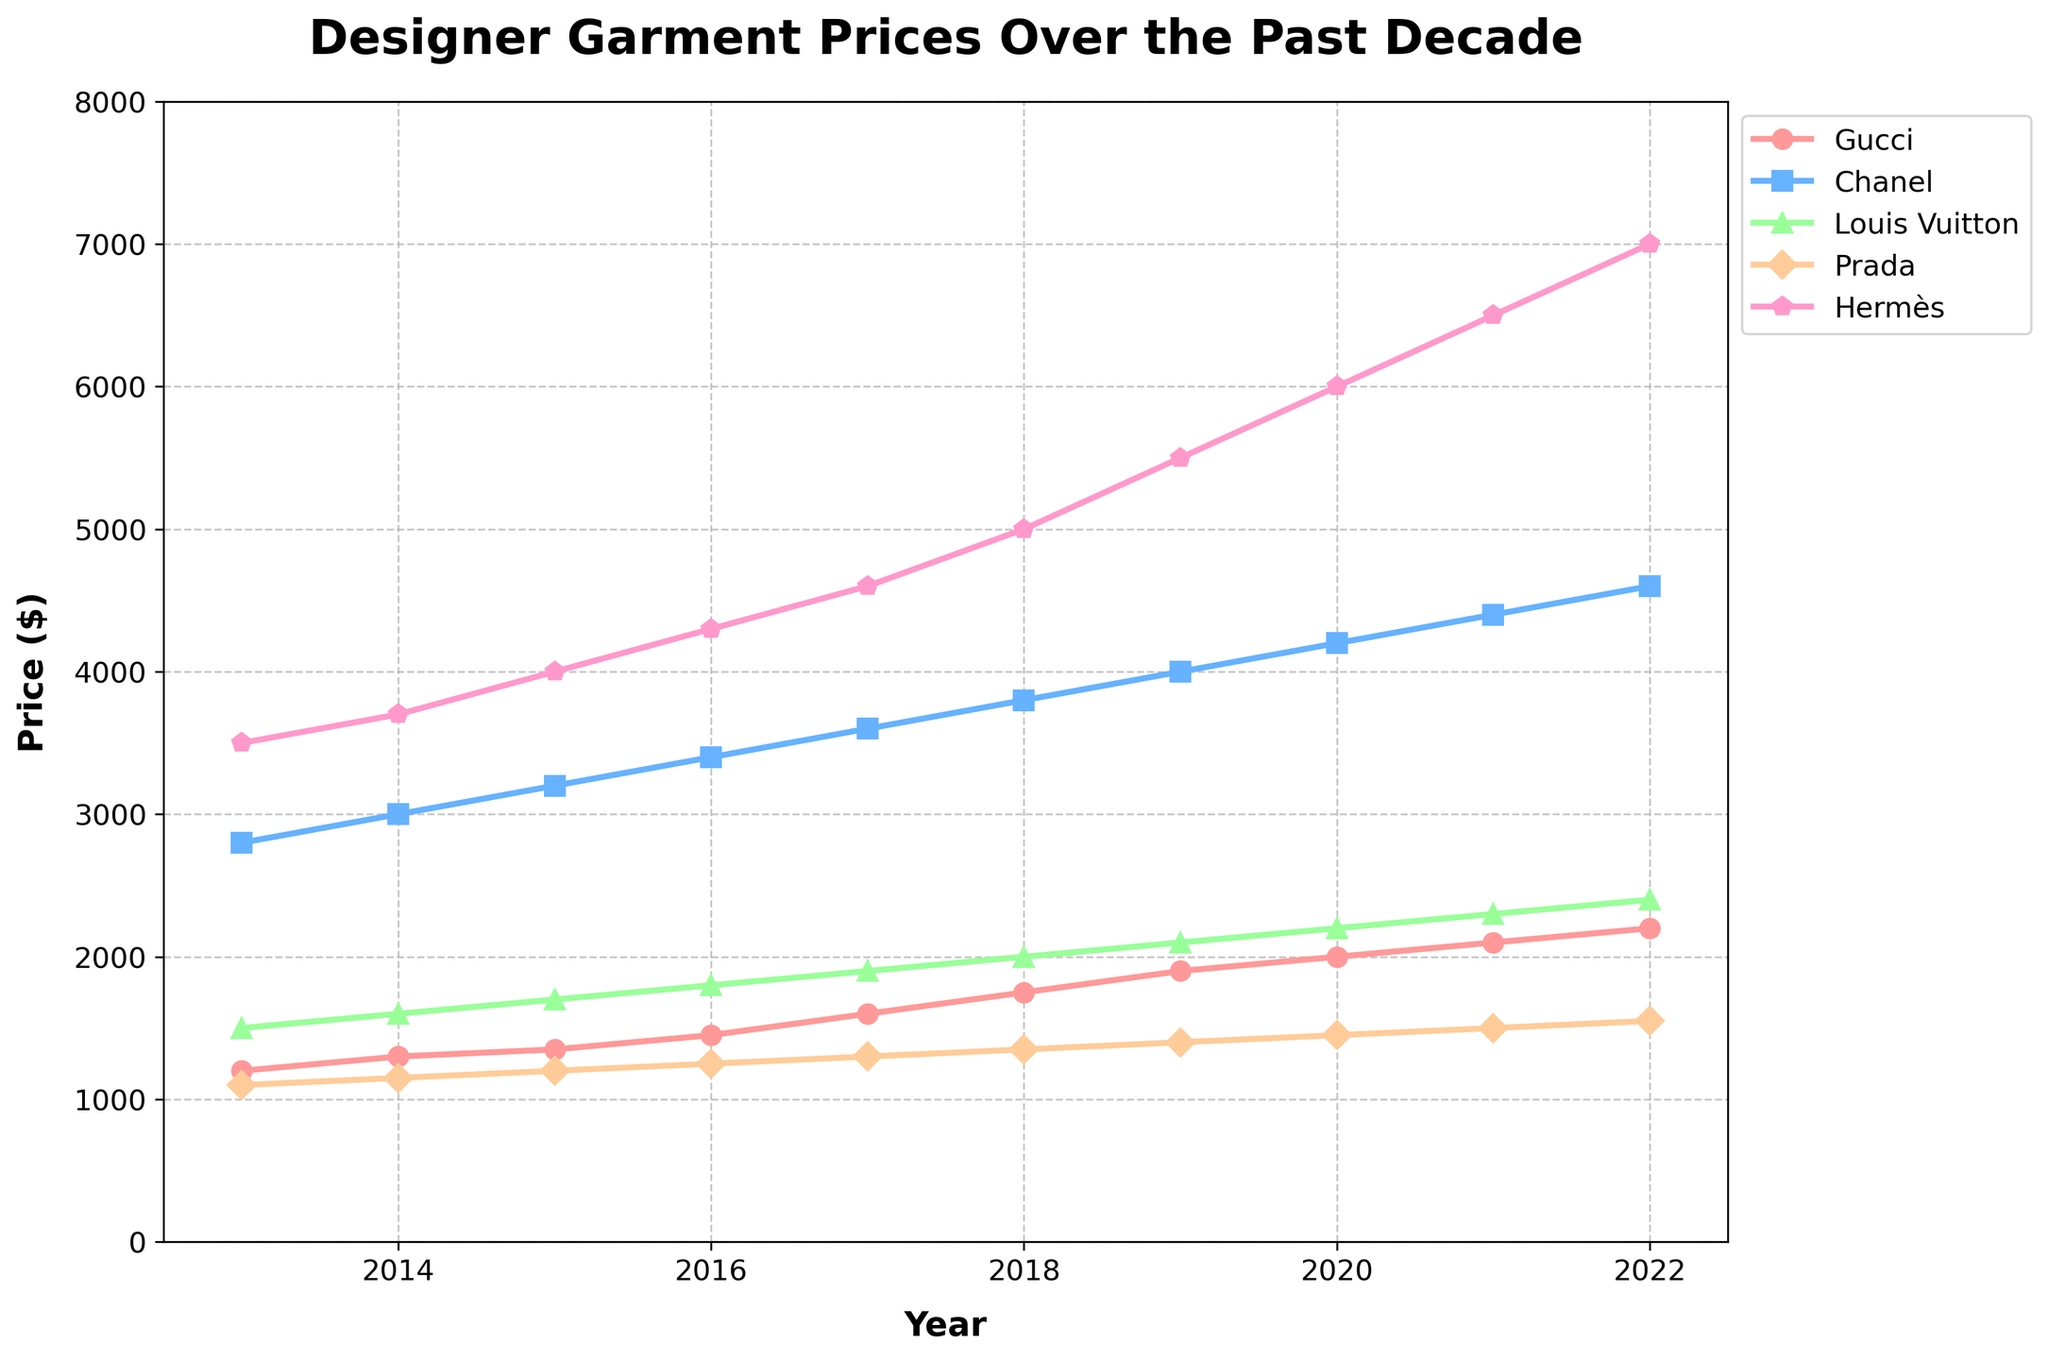What is the overall trend of designer garment prices for Gucci over the past decade? The overall trend for Gucci prices shows a steady increase from 2013 to 2022, starting at $1200 in 2013 and reaching $2200 in 2022. To determine this, observe the upward slope of the Gucci line over the years on the chart.
Answer: Steady increase Between 2013 and 2022, which brand had the highest percentage increase in garment prices? Calculate the percentage increase for each brand using the formula: (price in 2022 - price in 2013) / price in 2013 * 100%. For Hermès: (7000 - 3500) / 3500 * 100% = 100%; For Gucci: (2200 - 1200) / 1200 * 100% = 83.33%; For Chanel: (4600 - 2800) / 2800 * 100% = 64.29%; For Louis Vuitton: (2400 - 1500) / 1500 * 100% = 60%; For Prada: (1550 - 1100) / 1100 * 100% = 40.91%. Hermès has the highest percentage increase at 100%.
Answer: Hermès Which brand had the most consistent year-over-year price increase? The most consistent year-over-year price increase can be observed by identifying the brand whose line on the chart shows a nearly uniform slope without large fluctuations between years. Gucci, with a uniform increasing line from $1200 to $2200, appears most consistent.
Answer: Gucci In what year did Louis Vuitton surpass the $2000 price point? Look at the Louis Vuitton line and identify the year it crosses the $2000 price level. It crosses this level in 2022.
Answer: 2021 Compare the prices of Chanel and Prada in 2017. Which one was higher and by how much? Look at the values for Chanel and Prada in 2017. Chanel is $3600, and Prada is $1300. Subtract Prada's price from Chanel's: 3600 - 1300 = $2300. Chanel's price is higher by $2300.
Answer: Chanel by $2300 What is the average price of Hermès garments over the decade? Sum up Hermès prices from 2013 to 2022 and divide by the number of years (10): (3500 + 3700 + 4000 + 4300 + 4600 + 5000 + 5500 + 6000 + 6500 + 7000) / 10 = 50100 / 10 = $5010.
Answer: $5010 Is there any brand whose price never exceeded $3000 in any of the years? Check the maximum prices for each brand. Prada's price never exceeded $3000, peaking at $1550 in 2022.
Answer: Prada Which year saw the largest single-year increase in price for Louis Vuitton garments? Look at the differences between consecutive years for Louis Vuitton: between 2017 ($1900) and 2018 ($2000) is the largest single-year increase of $100.
Answer: 2017 to 2018 By how much did Prada's price increase from 2013 to 2020? Subtract the 2013 price of Prada from its 2020 price: 1450 - 1100 = $350.
Answer: $350 In the year 2020, which brand had the lowest price and what was it? Look at the prices for all brands in 2020. Prada had the lowest price at $1450.
Answer: Prada, $1450 